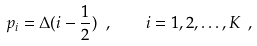Convert formula to latex. <formula><loc_0><loc_0><loc_500><loc_500>p _ { i } = \Delta ( i - \frac { 1 } { 2 } ) \ , \quad i = 1 , 2 , \dots , K \ ,</formula> 